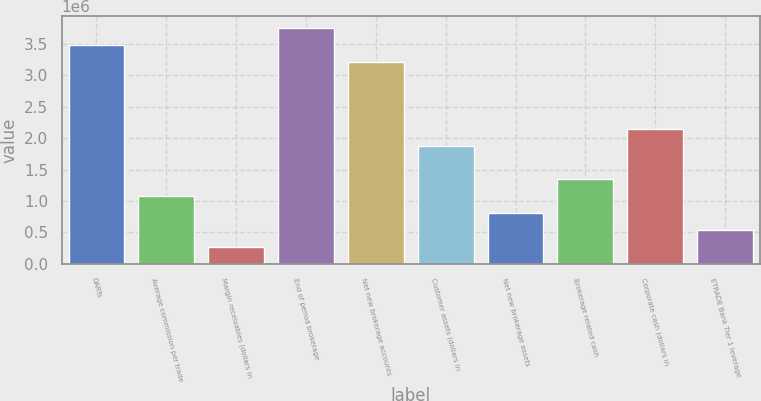<chart> <loc_0><loc_0><loc_500><loc_500><bar_chart><fcel>DARTs<fcel>Average commission per trade<fcel>Margin receivables (dollars in<fcel>End of period brokerage<fcel>Net new brokerage accounts<fcel>Customer assets (dollars in<fcel>Net new brokerage assets<fcel>Brokerage related cash<fcel>Corporate cash (dollars in<fcel>ETRADE Bank Tier 1 leverage<nl><fcel>3.4896e+06<fcel>1.07373e+06<fcel>268434<fcel>3.75803e+06<fcel>3.22117e+06<fcel>1.87902e+06<fcel>805295<fcel>1.34216e+06<fcel>2.14745e+06<fcel>536865<nl></chart> 